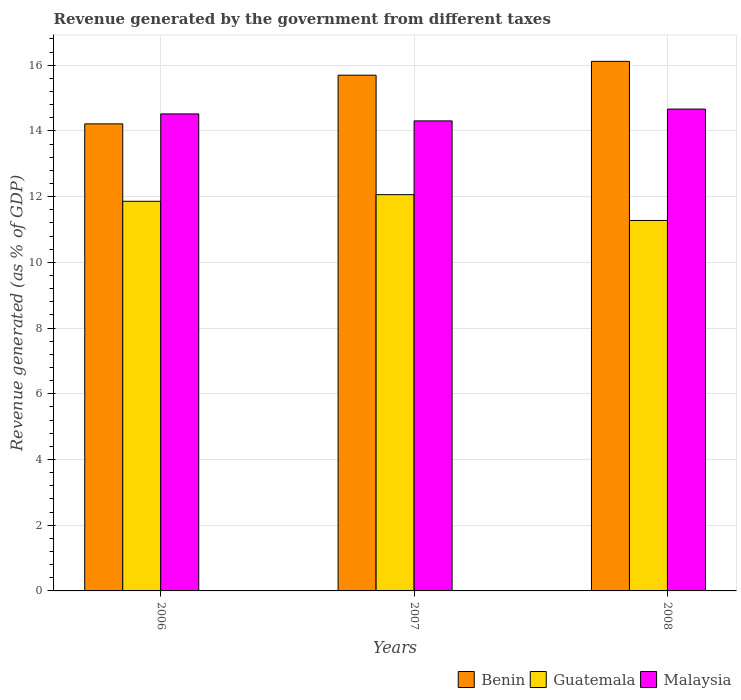How many different coloured bars are there?
Offer a very short reply. 3. What is the revenue generated by the government in Benin in 2007?
Your response must be concise. 15.69. Across all years, what is the maximum revenue generated by the government in Guatemala?
Provide a succinct answer. 12.06. Across all years, what is the minimum revenue generated by the government in Guatemala?
Keep it short and to the point. 11.27. In which year was the revenue generated by the government in Benin maximum?
Offer a terse response. 2008. In which year was the revenue generated by the government in Benin minimum?
Offer a terse response. 2006. What is the total revenue generated by the government in Malaysia in the graph?
Ensure brevity in your answer.  43.48. What is the difference between the revenue generated by the government in Benin in 2007 and that in 2008?
Your answer should be very brief. -0.42. What is the difference between the revenue generated by the government in Benin in 2008 and the revenue generated by the government in Malaysia in 2006?
Offer a very short reply. 1.6. What is the average revenue generated by the government in Malaysia per year?
Keep it short and to the point. 14.49. In the year 2006, what is the difference between the revenue generated by the government in Guatemala and revenue generated by the government in Benin?
Offer a terse response. -2.36. What is the ratio of the revenue generated by the government in Benin in 2006 to that in 2007?
Offer a terse response. 0.91. Is the revenue generated by the government in Malaysia in 2006 less than that in 2008?
Ensure brevity in your answer.  Yes. What is the difference between the highest and the second highest revenue generated by the government in Guatemala?
Offer a very short reply. 0.2. What is the difference between the highest and the lowest revenue generated by the government in Benin?
Your answer should be very brief. 1.9. In how many years, is the revenue generated by the government in Guatemala greater than the average revenue generated by the government in Guatemala taken over all years?
Ensure brevity in your answer.  2. What does the 2nd bar from the left in 2007 represents?
Your answer should be compact. Guatemala. What does the 2nd bar from the right in 2007 represents?
Your response must be concise. Guatemala. Is it the case that in every year, the sum of the revenue generated by the government in Guatemala and revenue generated by the government in Benin is greater than the revenue generated by the government in Malaysia?
Offer a very short reply. Yes. Are all the bars in the graph horizontal?
Provide a short and direct response. No. Does the graph contain grids?
Keep it short and to the point. Yes. Where does the legend appear in the graph?
Give a very brief answer. Bottom right. What is the title of the graph?
Your answer should be compact. Revenue generated by the government from different taxes. What is the label or title of the X-axis?
Provide a short and direct response. Years. What is the label or title of the Y-axis?
Offer a terse response. Revenue generated (as % of GDP). What is the Revenue generated (as % of GDP) in Benin in 2006?
Your response must be concise. 14.21. What is the Revenue generated (as % of GDP) of Guatemala in 2006?
Your answer should be very brief. 11.86. What is the Revenue generated (as % of GDP) in Malaysia in 2006?
Your answer should be very brief. 14.52. What is the Revenue generated (as % of GDP) of Benin in 2007?
Ensure brevity in your answer.  15.69. What is the Revenue generated (as % of GDP) of Guatemala in 2007?
Offer a very short reply. 12.06. What is the Revenue generated (as % of GDP) of Malaysia in 2007?
Your answer should be compact. 14.3. What is the Revenue generated (as % of GDP) in Benin in 2008?
Ensure brevity in your answer.  16.12. What is the Revenue generated (as % of GDP) in Guatemala in 2008?
Provide a succinct answer. 11.27. What is the Revenue generated (as % of GDP) in Malaysia in 2008?
Provide a short and direct response. 14.66. Across all years, what is the maximum Revenue generated (as % of GDP) of Benin?
Provide a succinct answer. 16.12. Across all years, what is the maximum Revenue generated (as % of GDP) of Guatemala?
Your answer should be compact. 12.06. Across all years, what is the maximum Revenue generated (as % of GDP) of Malaysia?
Ensure brevity in your answer.  14.66. Across all years, what is the minimum Revenue generated (as % of GDP) in Benin?
Your answer should be very brief. 14.21. Across all years, what is the minimum Revenue generated (as % of GDP) of Guatemala?
Offer a terse response. 11.27. Across all years, what is the minimum Revenue generated (as % of GDP) of Malaysia?
Ensure brevity in your answer.  14.3. What is the total Revenue generated (as % of GDP) of Benin in the graph?
Offer a very short reply. 46.02. What is the total Revenue generated (as % of GDP) of Guatemala in the graph?
Offer a very short reply. 35.19. What is the total Revenue generated (as % of GDP) in Malaysia in the graph?
Make the answer very short. 43.48. What is the difference between the Revenue generated (as % of GDP) of Benin in 2006 and that in 2007?
Give a very brief answer. -1.48. What is the difference between the Revenue generated (as % of GDP) of Guatemala in 2006 and that in 2007?
Offer a very short reply. -0.2. What is the difference between the Revenue generated (as % of GDP) of Malaysia in 2006 and that in 2007?
Make the answer very short. 0.21. What is the difference between the Revenue generated (as % of GDP) of Benin in 2006 and that in 2008?
Give a very brief answer. -1.9. What is the difference between the Revenue generated (as % of GDP) of Guatemala in 2006 and that in 2008?
Keep it short and to the point. 0.58. What is the difference between the Revenue generated (as % of GDP) of Malaysia in 2006 and that in 2008?
Offer a very short reply. -0.15. What is the difference between the Revenue generated (as % of GDP) of Benin in 2007 and that in 2008?
Your answer should be compact. -0.42. What is the difference between the Revenue generated (as % of GDP) of Guatemala in 2007 and that in 2008?
Your answer should be very brief. 0.79. What is the difference between the Revenue generated (as % of GDP) in Malaysia in 2007 and that in 2008?
Give a very brief answer. -0.36. What is the difference between the Revenue generated (as % of GDP) in Benin in 2006 and the Revenue generated (as % of GDP) in Guatemala in 2007?
Keep it short and to the point. 2.15. What is the difference between the Revenue generated (as % of GDP) of Benin in 2006 and the Revenue generated (as % of GDP) of Malaysia in 2007?
Offer a terse response. -0.09. What is the difference between the Revenue generated (as % of GDP) of Guatemala in 2006 and the Revenue generated (as % of GDP) of Malaysia in 2007?
Keep it short and to the point. -2.45. What is the difference between the Revenue generated (as % of GDP) in Benin in 2006 and the Revenue generated (as % of GDP) in Guatemala in 2008?
Make the answer very short. 2.94. What is the difference between the Revenue generated (as % of GDP) in Benin in 2006 and the Revenue generated (as % of GDP) in Malaysia in 2008?
Provide a succinct answer. -0.45. What is the difference between the Revenue generated (as % of GDP) in Guatemala in 2006 and the Revenue generated (as % of GDP) in Malaysia in 2008?
Offer a very short reply. -2.81. What is the difference between the Revenue generated (as % of GDP) of Benin in 2007 and the Revenue generated (as % of GDP) of Guatemala in 2008?
Give a very brief answer. 4.42. What is the difference between the Revenue generated (as % of GDP) in Benin in 2007 and the Revenue generated (as % of GDP) in Malaysia in 2008?
Keep it short and to the point. 1.03. What is the difference between the Revenue generated (as % of GDP) in Guatemala in 2007 and the Revenue generated (as % of GDP) in Malaysia in 2008?
Give a very brief answer. -2.6. What is the average Revenue generated (as % of GDP) of Benin per year?
Make the answer very short. 15.34. What is the average Revenue generated (as % of GDP) in Guatemala per year?
Your response must be concise. 11.73. What is the average Revenue generated (as % of GDP) in Malaysia per year?
Make the answer very short. 14.49. In the year 2006, what is the difference between the Revenue generated (as % of GDP) in Benin and Revenue generated (as % of GDP) in Guatemala?
Give a very brief answer. 2.36. In the year 2006, what is the difference between the Revenue generated (as % of GDP) of Benin and Revenue generated (as % of GDP) of Malaysia?
Keep it short and to the point. -0.3. In the year 2006, what is the difference between the Revenue generated (as % of GDP) of Guatemala and Revenue generated (as % of GDP) of Malaysia?
Offer a terse response. -2.66. In the year 2007, what is the difference between the Revenue generated (as % of GDP) of Benin and Revenue generated (as % of GDP) of Guatemala?
Give a very brief answer. 3.63. In the year 2007, what is the difference between the Revenue generated (as % of GDP) of Benin and Revenue generated (as % of GDP) of Malaysia?
Provide a short and direct response. 1.39. In the year 2007, what is the difference between the Revenue generated (as % of GDP) in Guatemala and Revenue generated (as % of GDP) in Malaysia?
Offer a terse response. -2.24. In the year 2008, what is the difference between the Revenue generated (as % of GDP) of Benin and Revenue generated (as % of GDP) of Guatemala?
Make the answer very short. 4.84. In the year 2008, what is the difference between the Revenue generated (as % of GDP) in Benin and Revenue generated (as % of GDP) in Malaysia?
Your response must be concise. 1.45. In the year 2008, what is the difference between the Revenue generated (as % of GDP) of Guatemala and Revenue generated (as % of GDP) of Malaysia?
Give a very brief answer. -3.39. What is the ratio of the Revenue generated (as % of GDP) in Benin in 2006 to that in 2007?
Ensure brevity in your answer.  0.91. What is the ratio of the Revenue generated (as % of GDP) of Guatemala in 2006 to that in 2007?
Your answer should be compact. 0.98. What is the ratio of the Revenue generated (as % of GDP) in Malaysia in 2006 to that in 2007?
Provide a short and direct response. 1.01. What is the ratio of the Revenue generated (as % of GDP) of Benin in 2006 to that in 2008?
Keep it short and to the point. 0.88. What is the ratio of the Revenue generated (as % of GDP) in Guatemala in 2006 to that in 2008?
Make the answer very short. 1.05. What is the ratio of the Revenue generated (as % of GDP) in Malaysia in 2006 to that in 2008?
Provide a short and direct response. 0.99. What is the ratio of the Revenue generated (as % of GDP) in Benin in 2007 to that in 2008?
Give a very brief answer. 0.97. What is the ratio of the Revenue generated (as % of GDP) in Guatemala in 2007 to that in 2008?
Give a very brief answer. 1.07. What is the ratio of the Revenue generated (as % of GDP) in Malaysia in 2007 to that in 2008?
Offer a terse response. 0.98. What is the difference between the highest and the second highest Revenue generated (as % of GDP) in Benin?
Offer a terse response. 0.42. What is the difference between the highest and the second highest Revenue generated (as % of GDP) of Guatemala?
Make the answer very short. 0.2. What is the difference between the highest and the second highest Revenue generated (as % of GDP) of Malaysia?
Offer a very short reply. 0.15. What is the difference between the highest and the lowest Revenue generated (as % of GDP) of Benin?
Offer a very short reply. 1.9. What is the difference between the highest and the lowest Revenue generated (as % of GDP) of Guatemala?
Provide a succinct answer. 0.79. What is the difference between the highest and the lowest Revenue generated (as % of GDP) of Malaysia?
Provide a succinct answer. 0.36. 